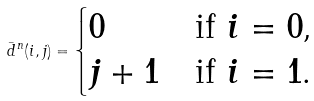Convert formula to latex. <formula><loc_0><loc_0><loc_500><loc_500>\bar { d } ^ { n } ( i , j ) = \begin{cases} 0 & \text {if $i=0$,} \\ j + 1 & \text {if $i=1$.} \end{cases}</formula> 